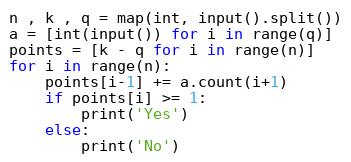Convert code to text. <code><loc_0><loc_0><loc_500><loc_500><_Python_>n , k , q = map(int, input().split())
a = [int(input()) for i in range(q)]
points = [k - q for i in range(n)]
for i in range(n):
    points[i-1] += a.count(i+1)
    if points[i] >= 1:
        print('Yes')
    else:
        print('No')</code> 